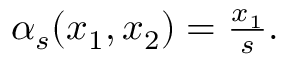<formula> <loc_0><loc_0><loc_500><loc_500>\begin{array} { r } { \alpha _ { s } ( x _ { 1 } , x _ { 2 } ) = \frac { x _ { 1 } } { s } . } \end{array}</formula> 